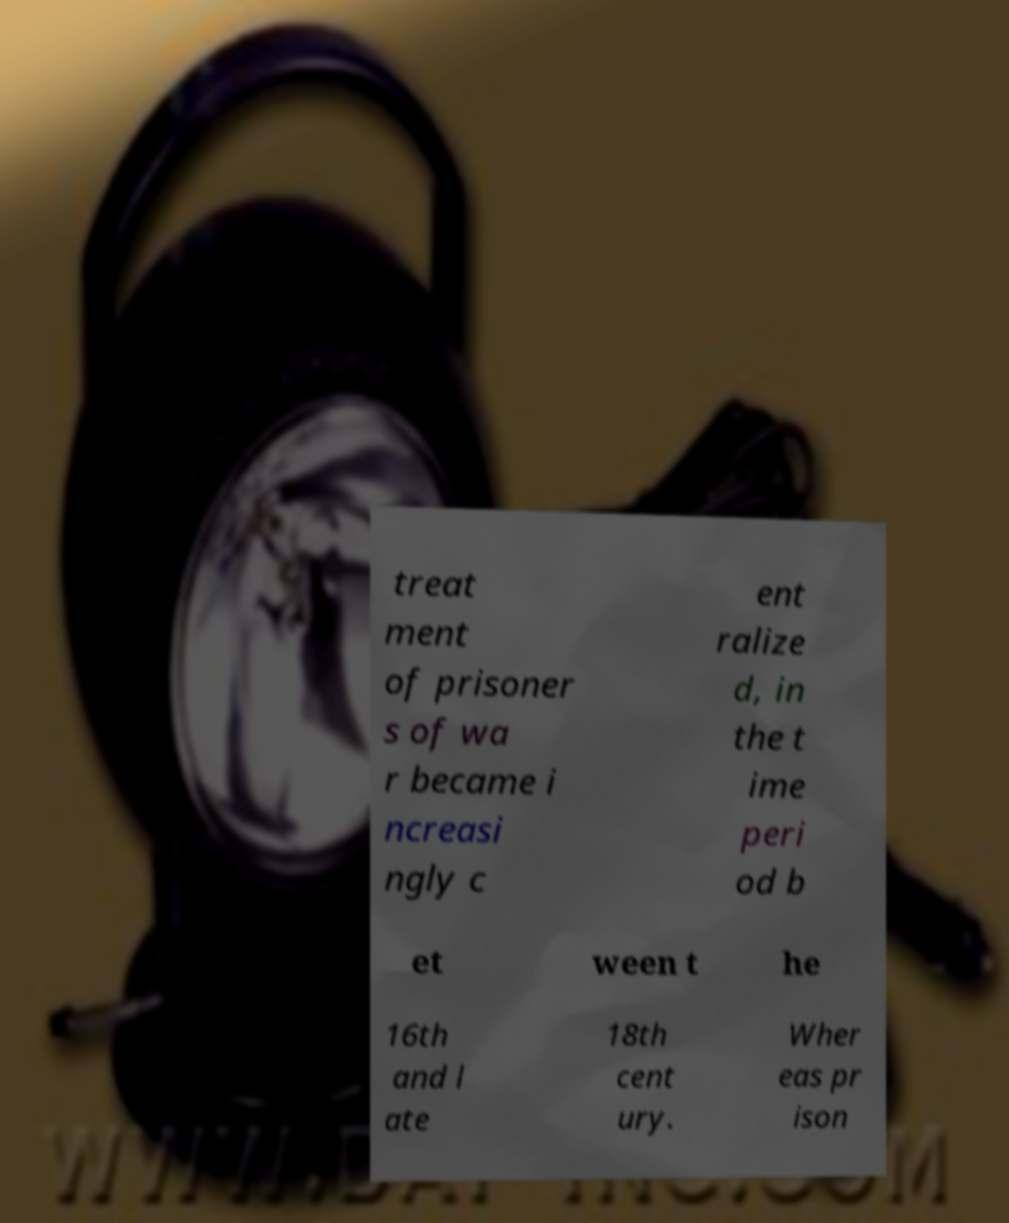Can you read and provide the text displayed in the image?This photo seems to have some interesting text. Can you extract and type it out for me? treat ment of prisoner s of wa r became i ncreasi ngly c ent ralize d, in the t ime peri od b et ween t he 16th and l ate 18th cent ury. Wher eas pr ison 